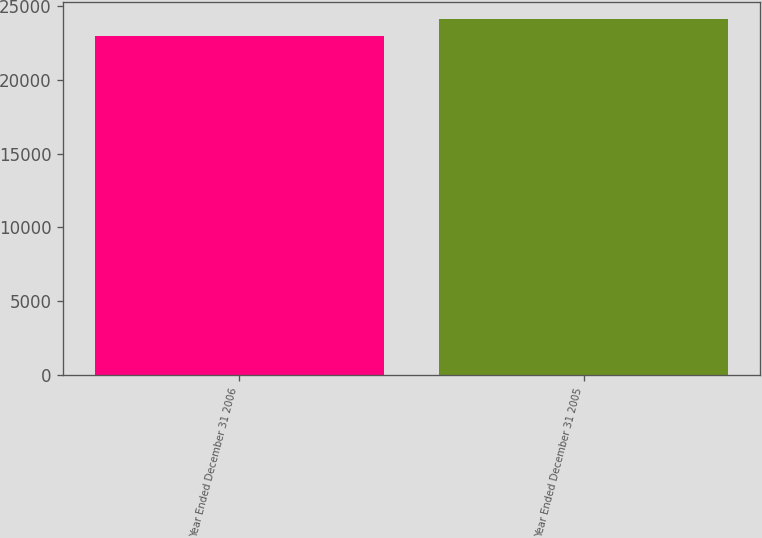Convert chart. <chart><loc_0><loc_0><loc_500><loc_500><bar_chart><fcel>Year Ended December 31 2006<fcel>Year Ended December 31 2005<nl><fcel>22958<fcel>24126<nl></chart> 